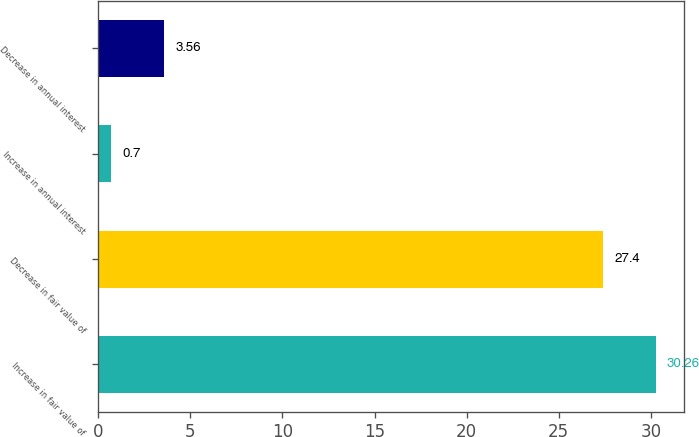Convert chart. <chart><loc_0><loc_0><loc_500><loc_500><bar_chart><fcel>Increase in fair value of<fcel>Decrease in fair value of<fcel>Increase in annual interest<fcel>Decrease in annual interest<nl><fcel>30.26<fcel>27.4<fcel>0.7<fcel>3.56<nl></chart> 